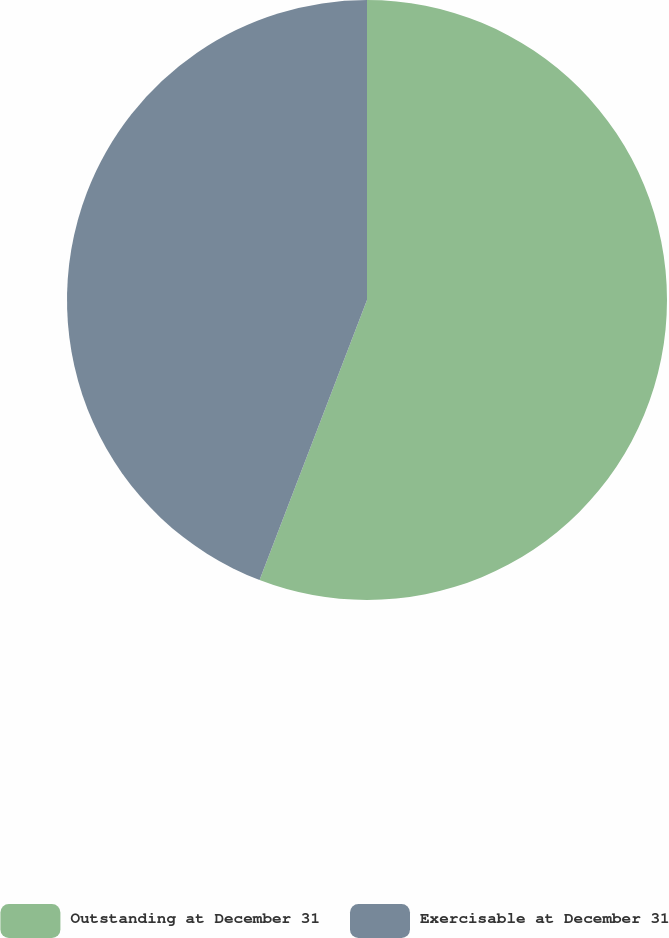Convert chart to OTSL. <chart><loc_0><loc_0><loc_500><loc_500><pie_chart><fcel>Outstanding at December 31<fcel>Exercisable at December 31<nl><fcel>55.83%<fcel>44.17%<nl></chart> 